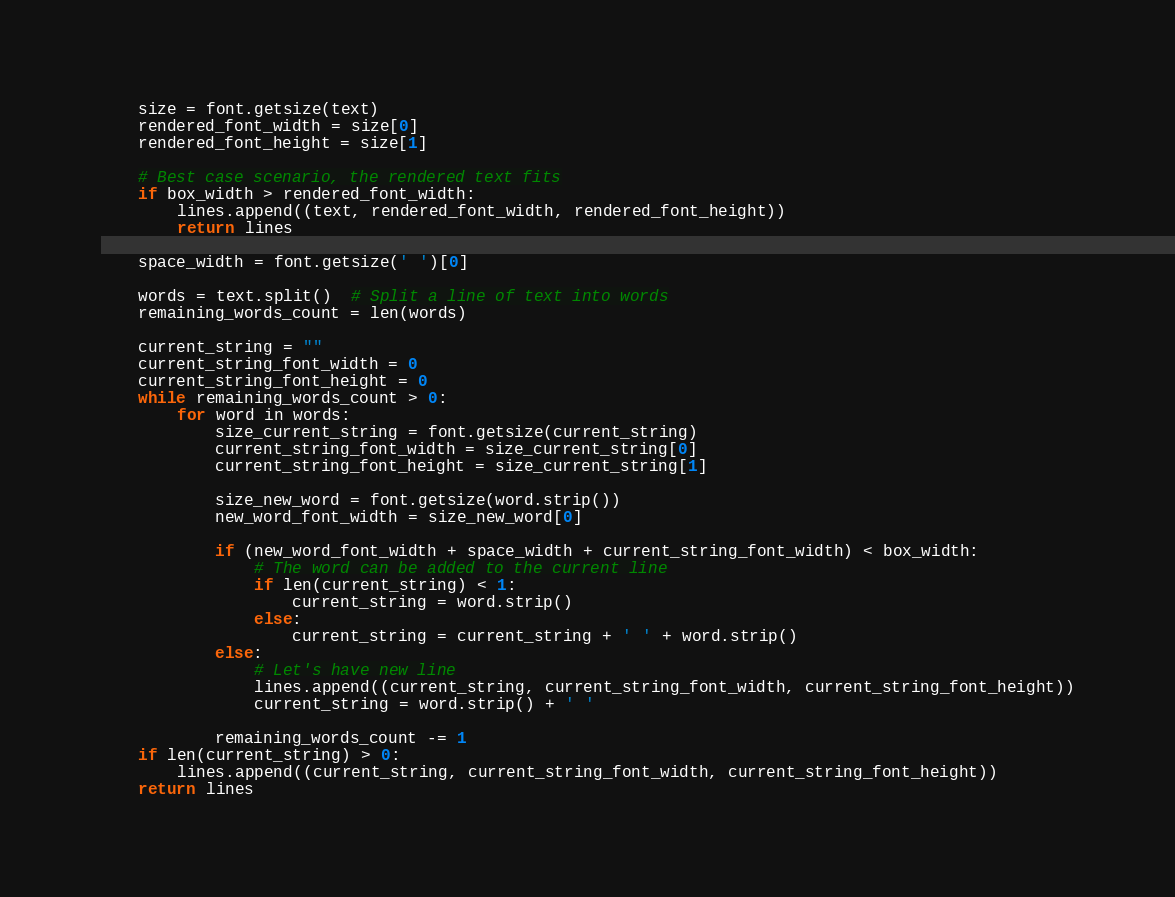Convert code to text. <code><loc_0><loc_0><loc_500><loc_500><_Python_>    size = font.getsize(text)
    rendered_font_width = size[0]
    rendered_font_height = size[1]

    # Best case scenario, the rendered text fits
    if box_width > rendered_font_width:
        lines.append((text, rendered_font_width, rendered_font_height))
        return lines

    space_width = font.getsize(' ')[0]

    words = text.split()  # Split a line of text into words
    remaining_words_count = len(words)

    current_string = ""
    current_string_font_width = 0
    current_string_font_height = 0
    while remaining_words_count > 0:
        for word in words:
            size_current_string = font.getsize(current_string)
            current_string_font_width = size_current_string[0]
            current_string_font_height = size_current_string[1]

            size_new_word = font.getsize(word.strip())
            new_word_font_width = size_new_word[0]

            if (new_word_font_width + space_width + current_string_font_width) < box_width:
                # The word can be added to the current line
                if len(current_string) < 1:
                    current_string = word.strip()
                else:
                    current_string = current_string + ' ' + word.strip()
            else:
                # Let's have new line
                lines.append((current_string, current_string_font_width, current_string_font_height))
                current_string = word.strip() + ' '

            remaining_words_count -= 1
    if len(current_string) > 0:
        lines.append((current_string, current_string_font_width, current_string_font_height))
    return lines
</code> 